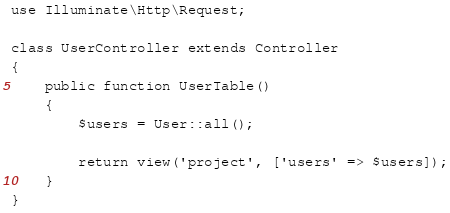<code> <loc_0><loc_0><loc_500><loc_500><_PHP_>

use Illuminate\Http\Request;

class UserController extends Controller
{
    public function UserTable()
    {
        $users = User::all();

        return view('project', ['users' => $users]);
    }
}
</code> 